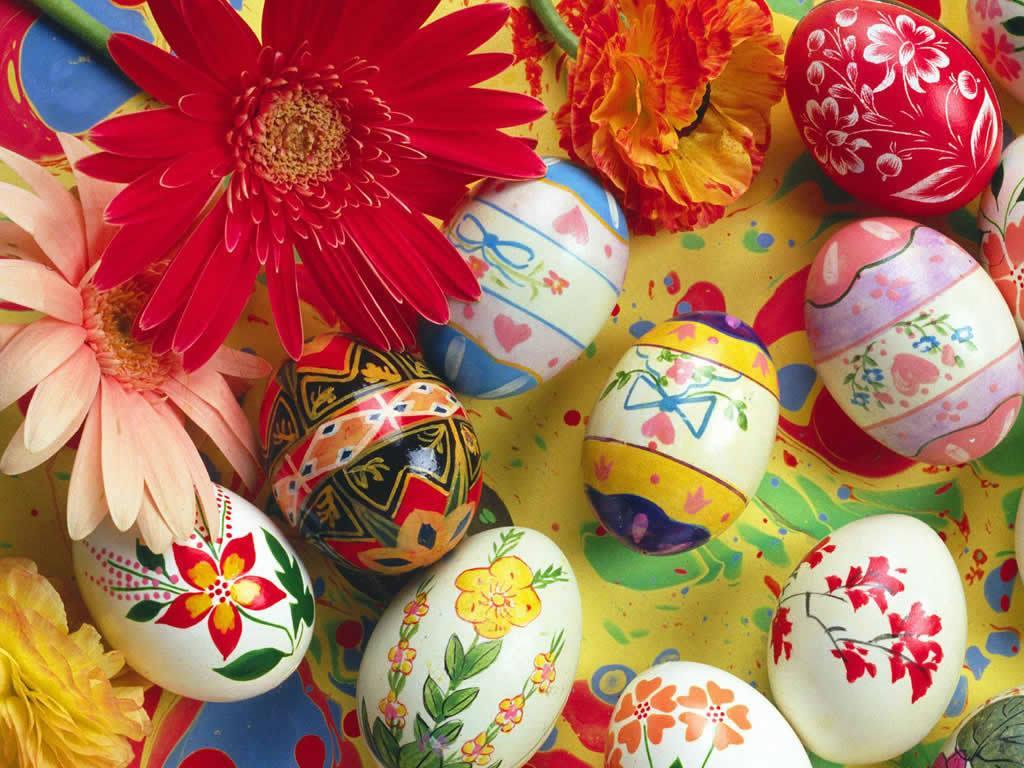Can you describe this image briefly? In this image I can see few deigned eggs and they are on the colorful floor. I can see red,peach,yellow and orange color flowers. 